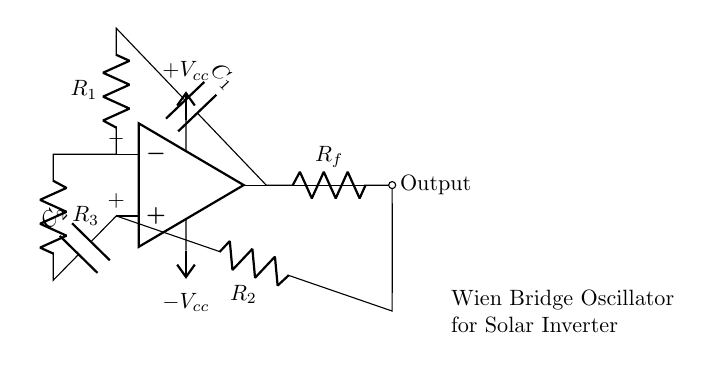What is the function of the op-amp in this circuit? The op-amp acts as a voltage amplifier, helping to stabilize and amplify the oscillation generated by the Wien bridge configuration.
Answer: Voltage amplifier What components are used in the feedback loop? The feedback loop consists of resistors R_f and R_2, which help control the gain of the op-amp and maintain stability in oscillation.
Answer: R_f and R_2 How many capacitors are present in the circuit? There are two capacitors, C_1 and C_2, which are integral to the frequency determination of the oscillator.
Answer: Two What is the purpose of the resistors R_1 and R_3? R_1 and R_3, along with C_1 and C_2, form the Wien bridge that determines the frequency of oscillation by balancing the gain.
Answer: Frequency determination What is the role of the power supply in this circuit? The power supply provides the necessary voltage levels, +V_cc and -V_cc, for the op-amp to operate and facilitate oscillation.
Answer: Voltage levels What type of waveform does the Wien bridge oscillator generate? The output waveform is typically a sine wave, produced due to the nature of the feedback network in the circuit.
Answer: Sine wave How does the circuit achieve stability in oscillation? Stability is achieved through carefully chosen resistor values and feedback configuration, balancing the gain exactly at unity.
Answer: Balancing gain at unity 